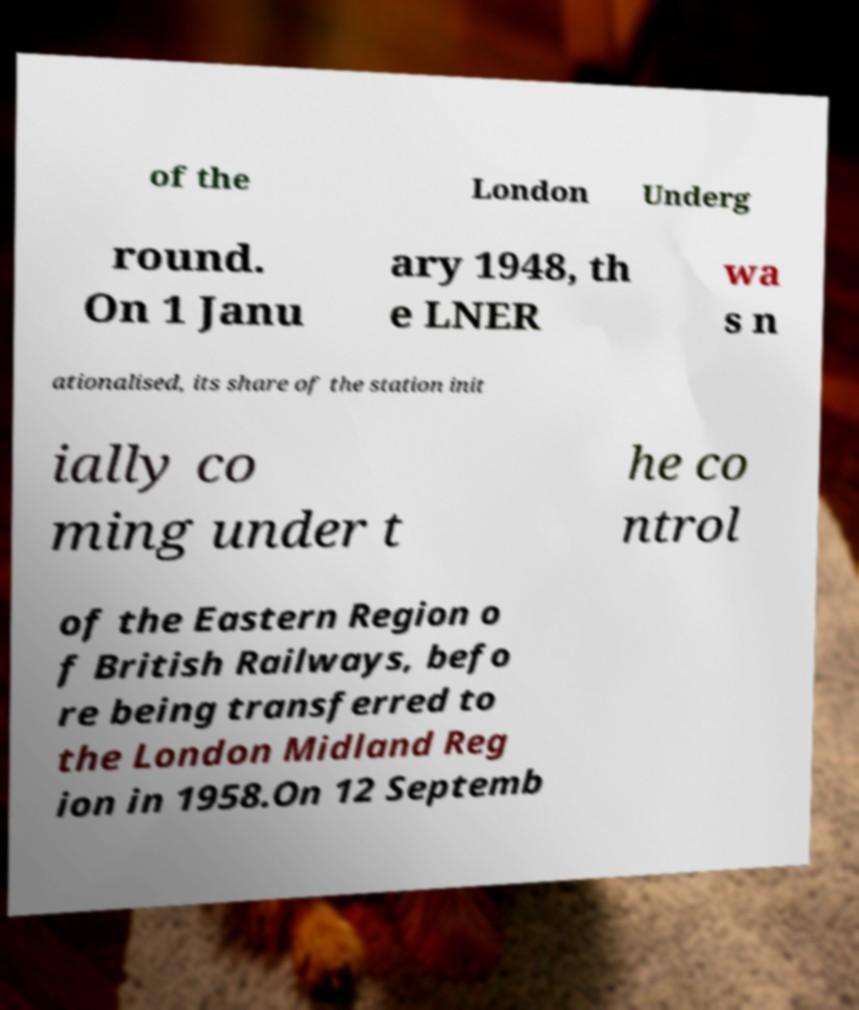Could you extract and type out the text from this image? of the London Underg round. On 1 Janu ary 1948, th e LNER wa s n ationalised, its share of the station init ially co ming under t he co ntrol of the Eastern Region o f British Railways, befo re being transferred to the London Midland Reg ion in 1958.On 12 Septemb 